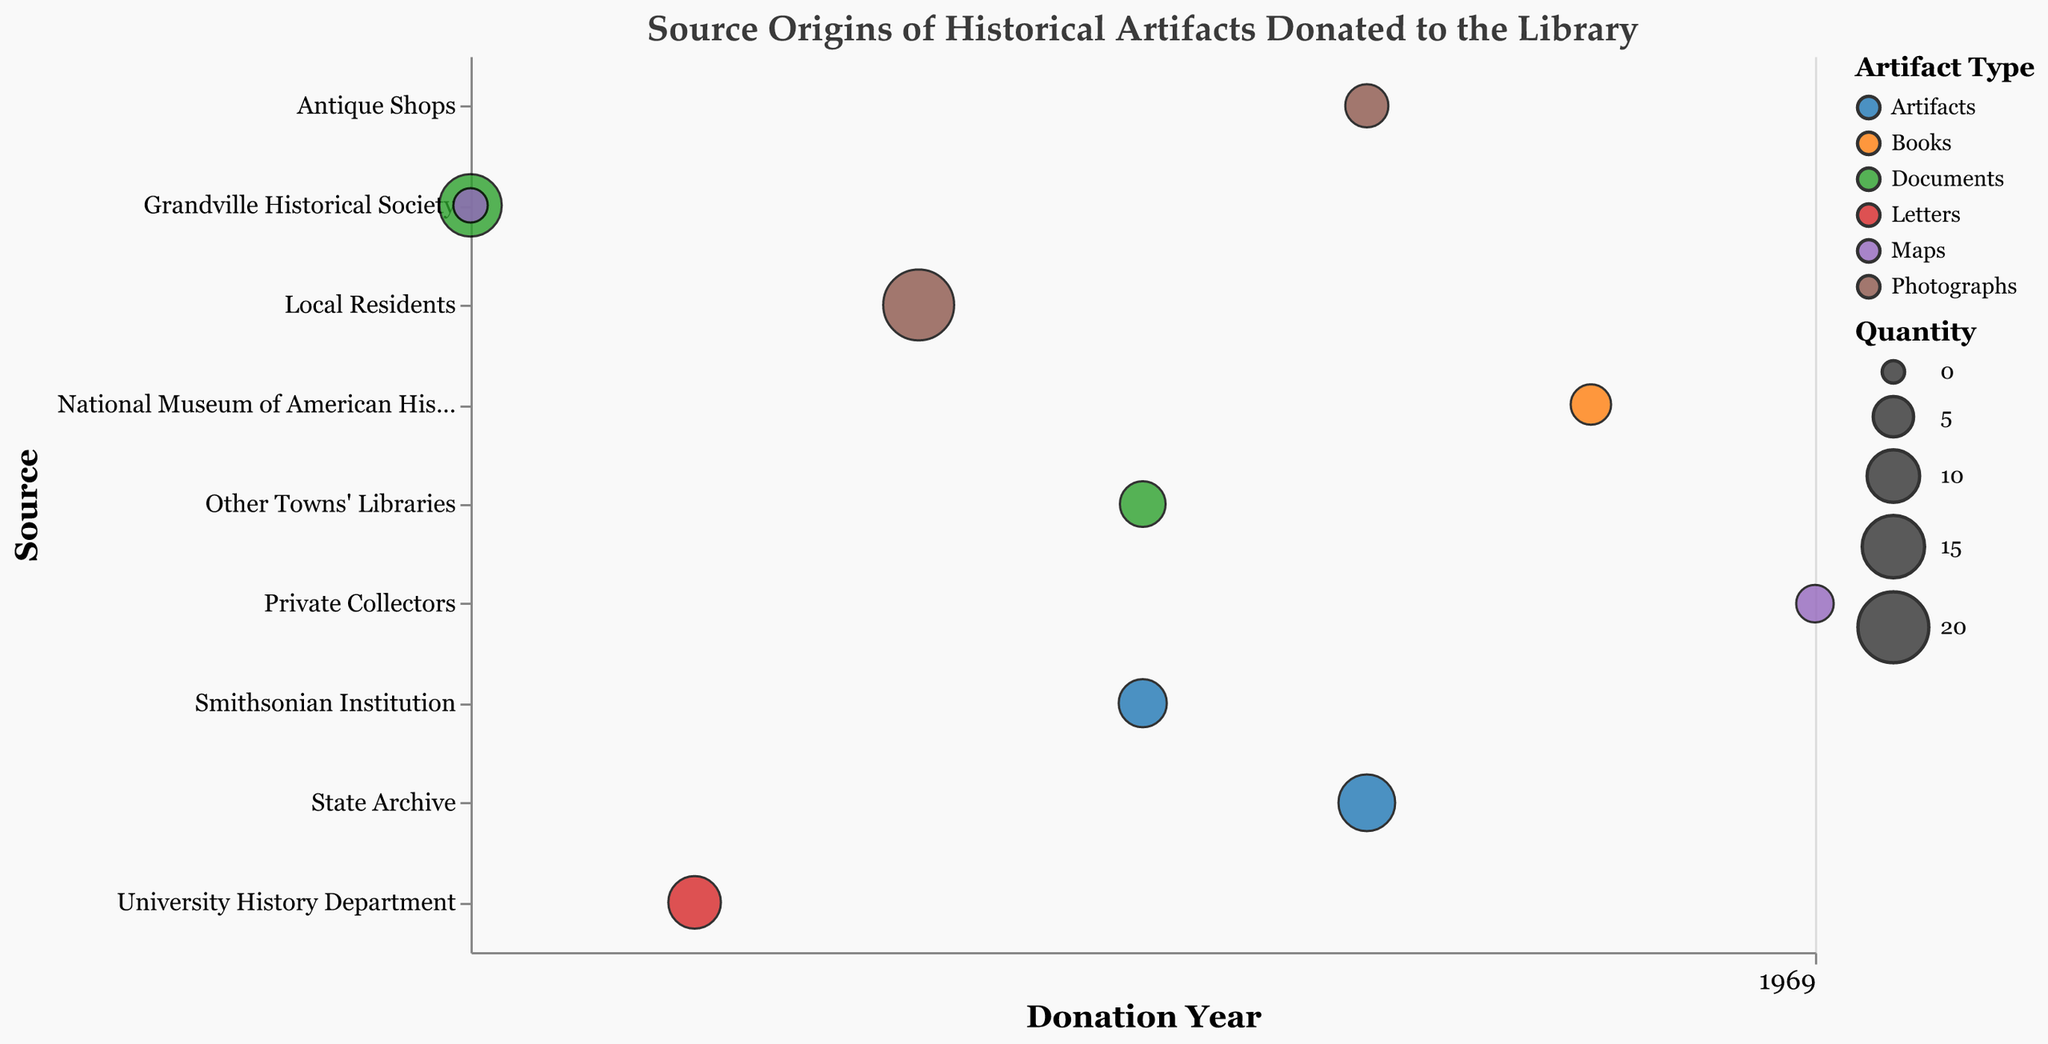What is the title of the chart? The chart has a visible title that clearly states the purpose of the visualization. By reading the text at the top of the chart, you can determine the title.
Answer: Source Origins of Historical Artifacts Donated to the Library Which source contributed the most photographs, and in what year? By identifying the largest bubble of the photographs color and then checking the year and source on the y-axis that correspond to this bubble.
Answer: Local Residents in 2017 How many sources donated artifacts? Artifacts can be identified by their specific color in the chart. By counting the individual sources (y-axis labels) associated with artifact bubbles, you can determine the number.
Answer: Two What is the total quantity of documents donated in 2015? By locating all the document bubbles for the year 2015 (x-axis) and summing their sizes, you get the total quantity.
Answer: 15 + 3 = 18 Which source donated books, and in what year? By identifying the bubble colored for books and locating the source (y-axis) and year (x-axis) associated with it, you can find the information.
Answer: National Museum of American History in 2020 Compare the number of artifacts donated by the Smithsonian Institution and the State Archive. Which donated more? By locating the artifact bubbles for both sources, check the quantity sizes indicated on the bubbles and compare them directly.
Answer: State Archive Which artifact types were donated by more than one source? Count the number of distinct sources (y-axis labels) associated with each artifact type color. Identify those associated with more than one source.
Answer: Documents and Photographs What is the average quantity of artifacts donated by the State Archive per year if they donated over multiple years? Find the total quantity of artifacts donated by the State Archive on multiple years, then divide by the number of years they donated in.
Answer: 12 (donated in one year, so 12/1 = 12) Which year had the highest total quantity of donations overall? Sum the quantities of all bubbles corresponding to each year on the x-axis and identify the year with the highest sum.
Answer: 2017 